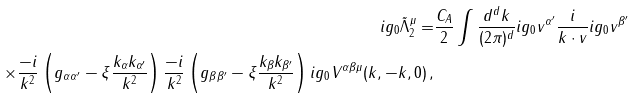Convert formula to latex. <formula><loc_0><loc_0><loc_500><loc_500>i g _ { 0 } \tilde { \Lambda } _ { 2 } ^ { \mu } = & \frac { C _ { A } } { 2 } \int \frac { d ^ { d } k } { ( 2 \pi ) ^ { d } } i g _ { 0 } v ^ { \alpha ^ { \prime } } \frac { i } { k \cdot v } i g _ { 0 } v ^ { \beta ^ { \prime } } \\ \times \frac { - i } { k ^ { 2 } } \left ( g _ { \alpha \alpha ^ { \prime } } - \xi \frac { k _ { \alpha } k _ { \alpha ^ { \prime } } } { k ^ { 2 } } \right ) \frac { - i } { k ^ { 2 } } \left ( g _ { \beta \beta ^ { \prime } } - \xi \frac { k _ { \beta } k _ { \beta ^ { \prime } } } { k ^ { 2 } } \right ) i g _ { 0 } V ^ { \alpha \beta \mu } ( k , - k , 0 ) \, ,</formula> 